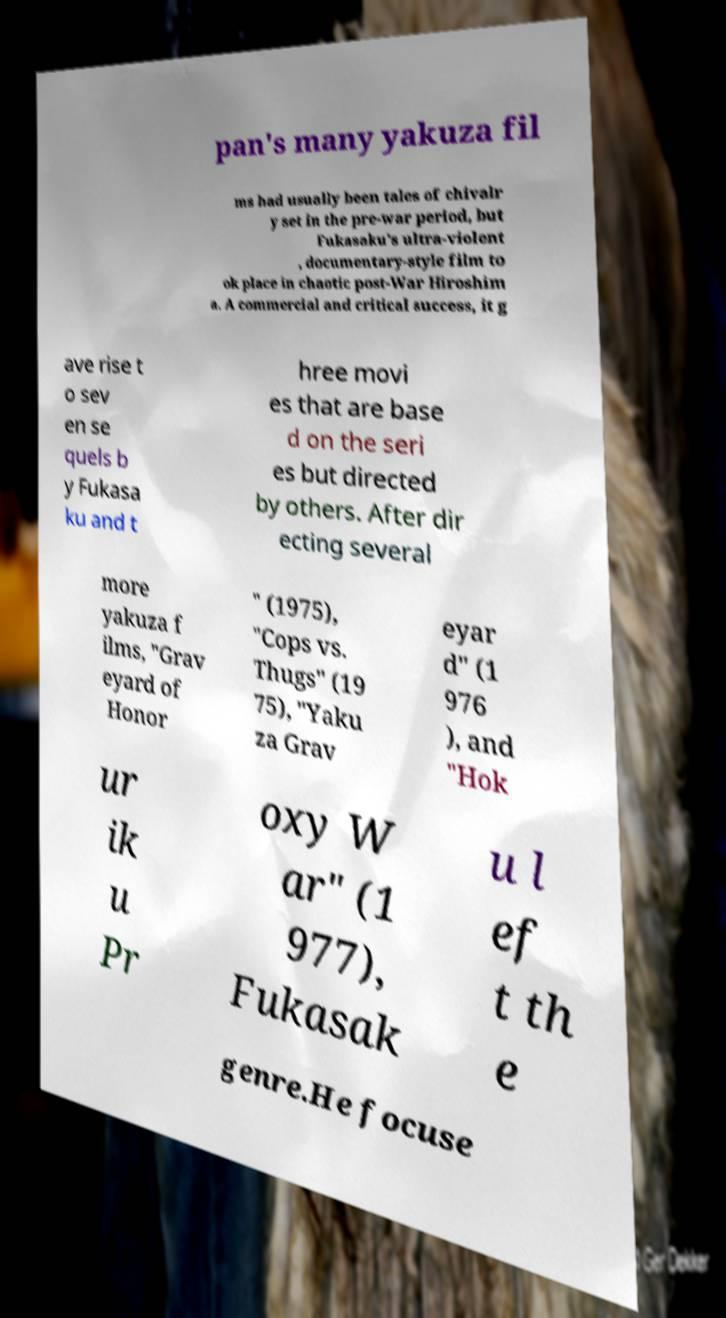Can you accurately transcribe the text from the provided image for me? pan's many yakuza fil ms had usually been tales of chivalr y set in the pre-war period, but Fukasaku's ultra-violent , documentary-style film to ok place in chaotic post-War Hiroshim a. A commercial and critical success, it g ave rise t o sev en se quels b y Fukasa ku and t hree movi es that are base d on the seri es but directed by others. After dir ecting several more yakuza f ilms, "Grav eyard of Honor " (1975), "Cops vs. Thugs" (19 75), "Yaku za Grav eyar d" (1 976 ), and "Hok ur ik u Pr oxy W ar" (1 977), Fukasak u l ef t th e genre.He focuse 